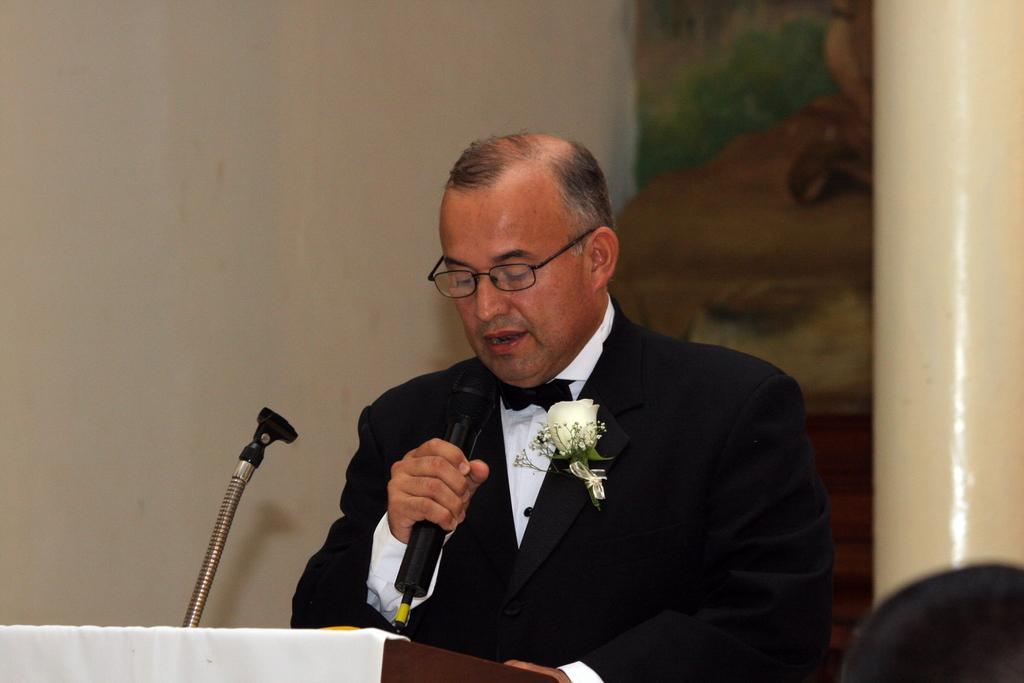Please provide a concise description of this image. There is a man holding a microphone and wore suit with flower and spectacle, in front of this man we can see podium with stand. Background we can see wall and pillar. 